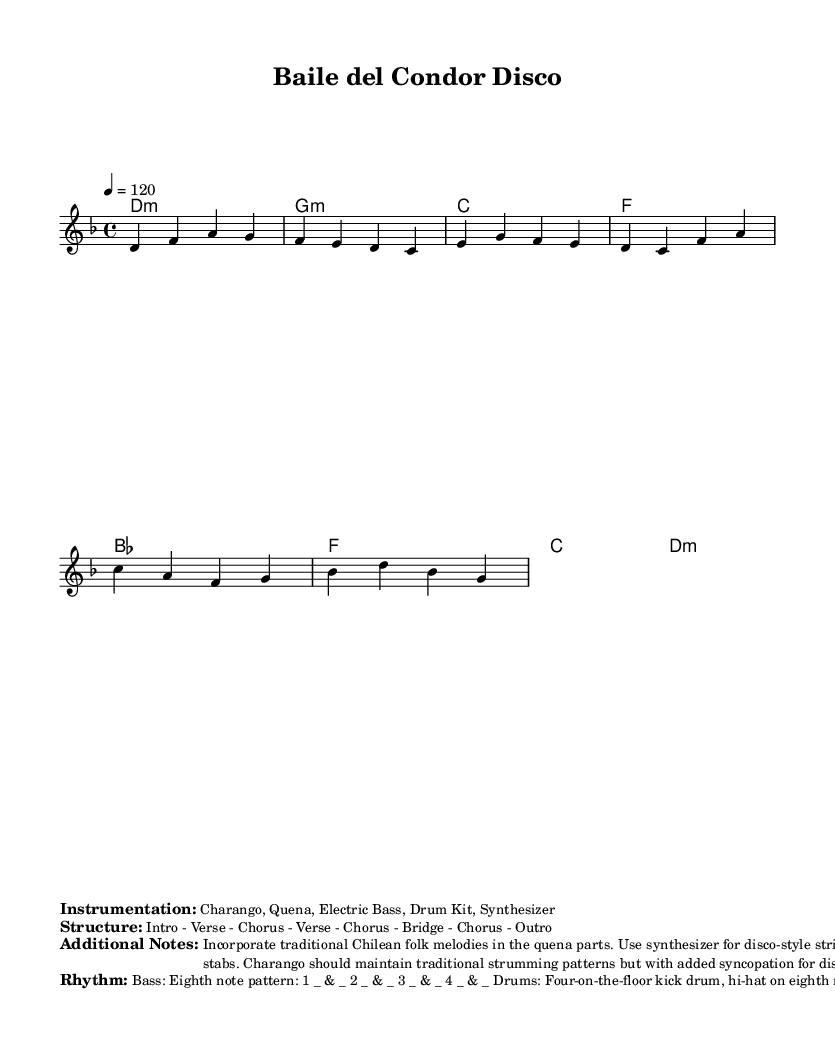What is the key signature of this music? The key signature indicates that the piece is in D minor, which has one flat (B flat). This is identified by looking at the key signature at the beginning of the staff notation.
Answer: D minor What is the time signature of this piece? The time signature is 4/4, which means there are four beats in each measure and a quarter note gets one beat. This is shown next to the clef in the music notation.
Answer: 4/4 What is the tempo marking for this music? The tempo marking is given as quarter note equals 120 beats per minute, which sets a moderate dance-like pace suggestive of disco music. This can be found in the tempo notation provided in the header.
Answer: 120 How many measures are in the chorus section? The chorus section consists of two measures, highlighted after the initial verse. This is identifiable by counting the measures labeled in the melody part.
Answer: 2 What instrumentation is specified for this piece? The instrumentation includes Charango, Quena, Electric Bass, Drum Kit, and Synthesizer. This information is listed under the "Instrumentation" markup, outlining the instruments to be used.
Answer: Charango, Quena, Electric Bass, Drum Kit, Synthesizer What type of rhythm is indicated for the bass? The bass rhythm is specified as an eighth note pattern with a consistent hit on each eighth note throughout the bar. This is detailed under the "Rhythm" markup in the sheet music.
Answer: Eighth note pattern What structure is given for this piece? The structure is presented as Intro - Verse - Chorus - Verse - Chorus - Bridge - Chorus - Outro, outlining the formal layout of the piece as marked in the score. This can be directly referred to in the section titled "Structure."
Answer: Intro - Verse - Chorus - Verse - Chorus - Bridge - Chorus - Outro 